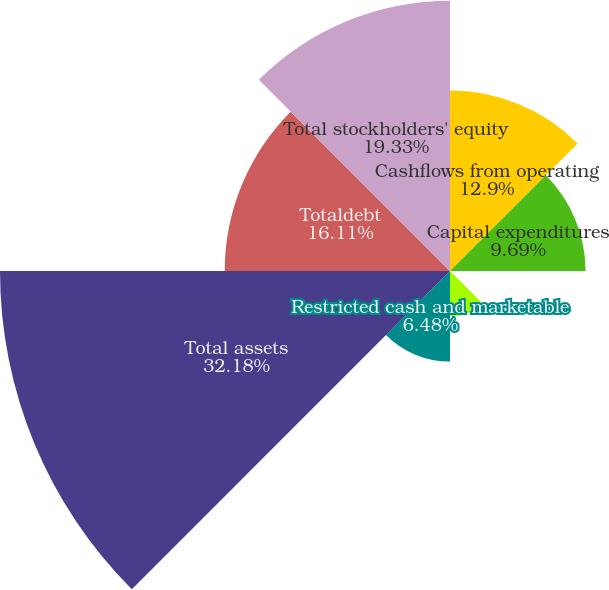Convert chart to OTSL. <chart><loc_0><loc_0><loc_500><loc_500><pie_chart><fcel>Cashflows from operating<fcel>Capital expenditures<fcel>Proceeds from sales of<fcel>Cash and cash equivalents<fcel>Restricted cash and marketable<fcel>Total assets<fcel>Totaldebt<fcel>Total stockholders' equity<nl><fcel>12.9%<fcel>9.69%<fcel>0.05%<fcel>3.26%<fcel>6.48%<fcel>32.18%<fcel>16.11%<fcel>19.33%<nl></chart> 